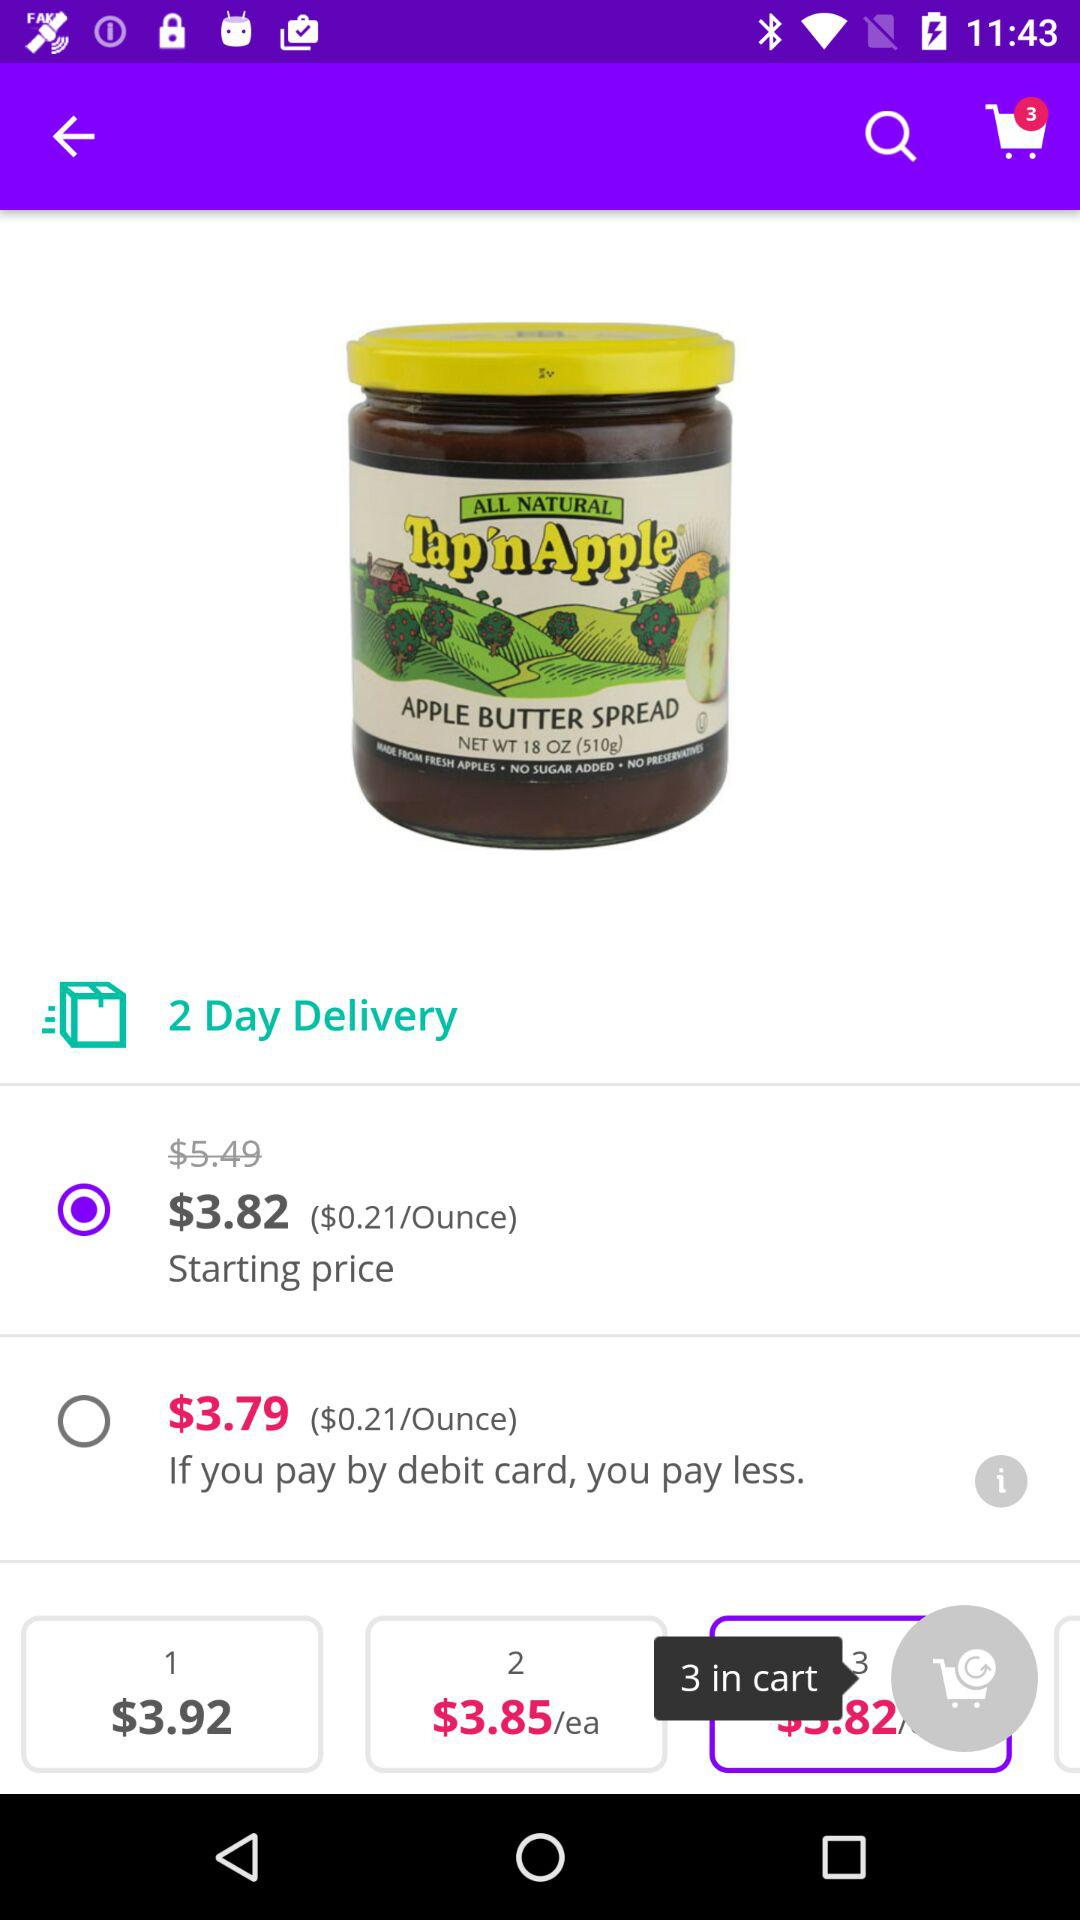What is the price if we pay by debit card? The price is $3.79. 